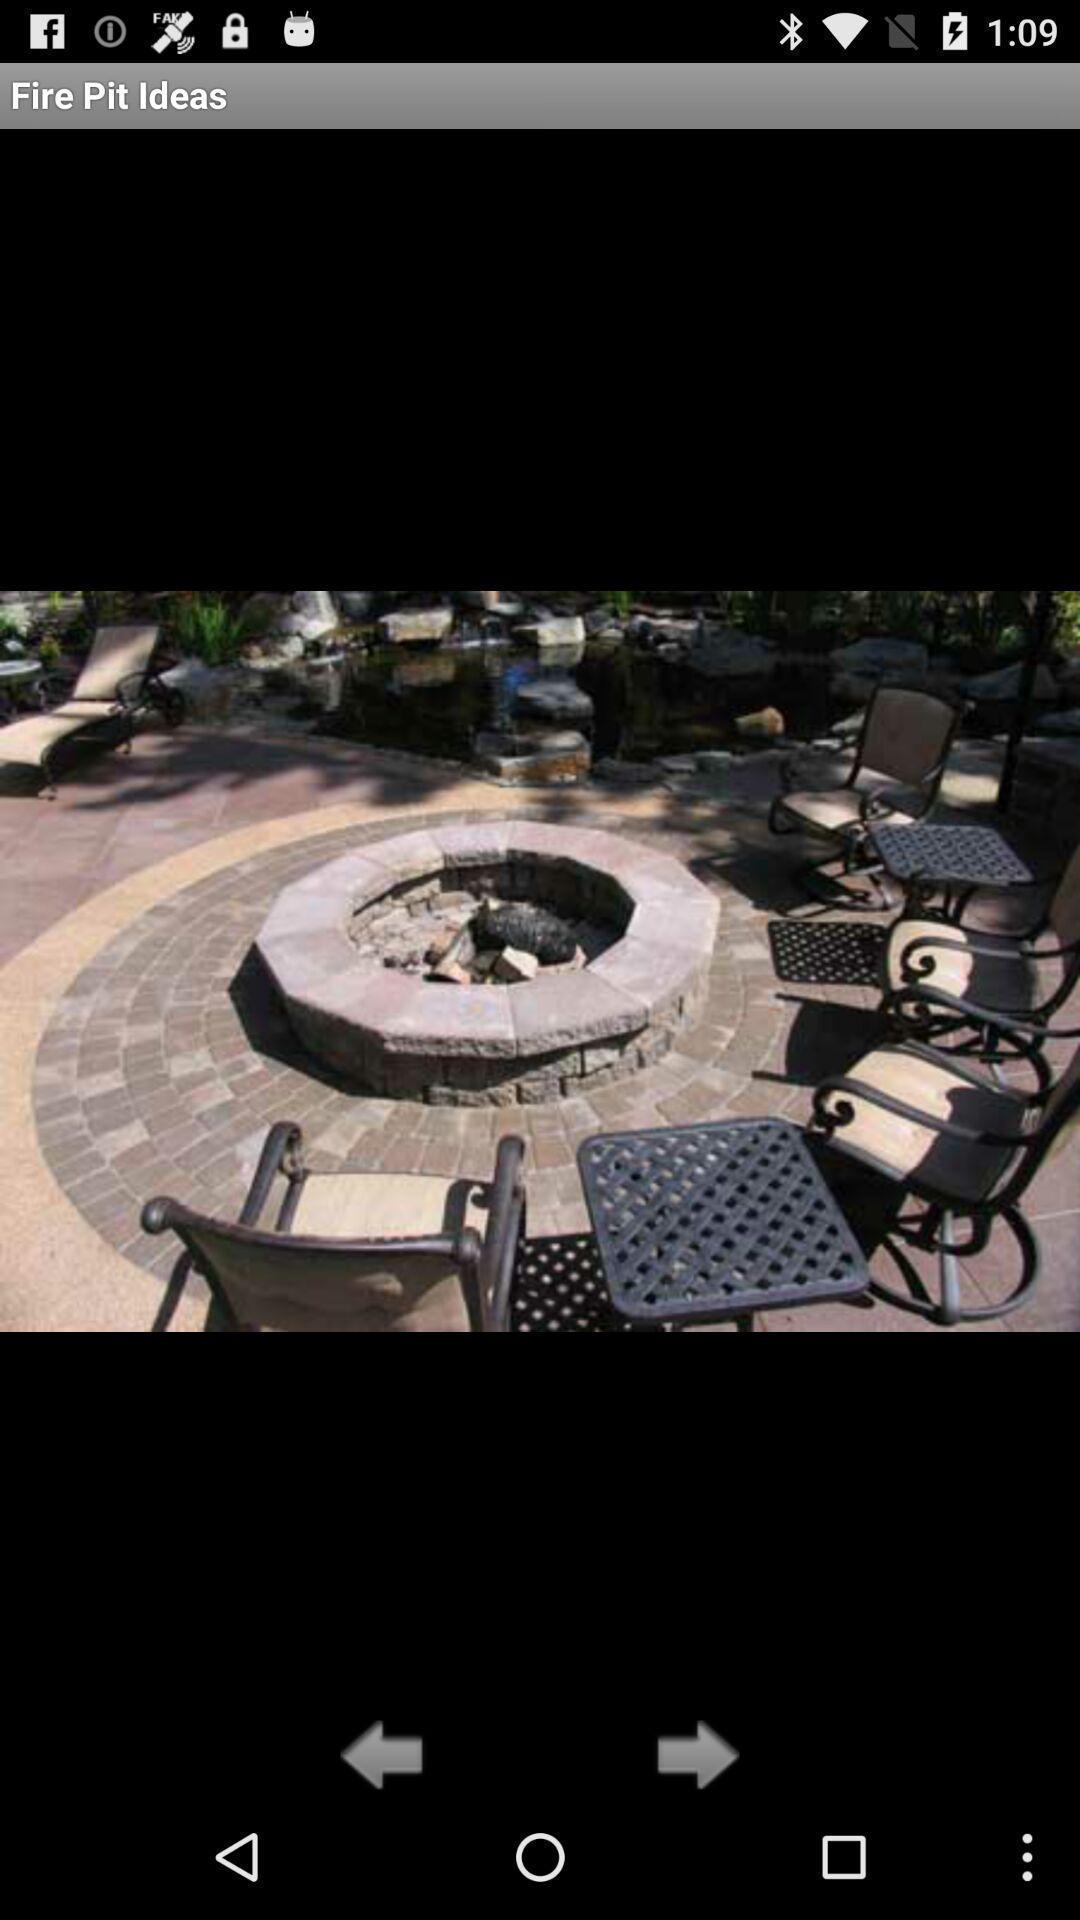Tell me about the visual elements in this screen capture. Screen showing the fire pit image. 